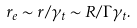Convert formula to latex. <formula><loc_0><loc_0><loc_500><loc_500>r _ { e } \sim r / \gamma _ { t } \sim R / \Gamma \gamma _ { t } .</formula> 